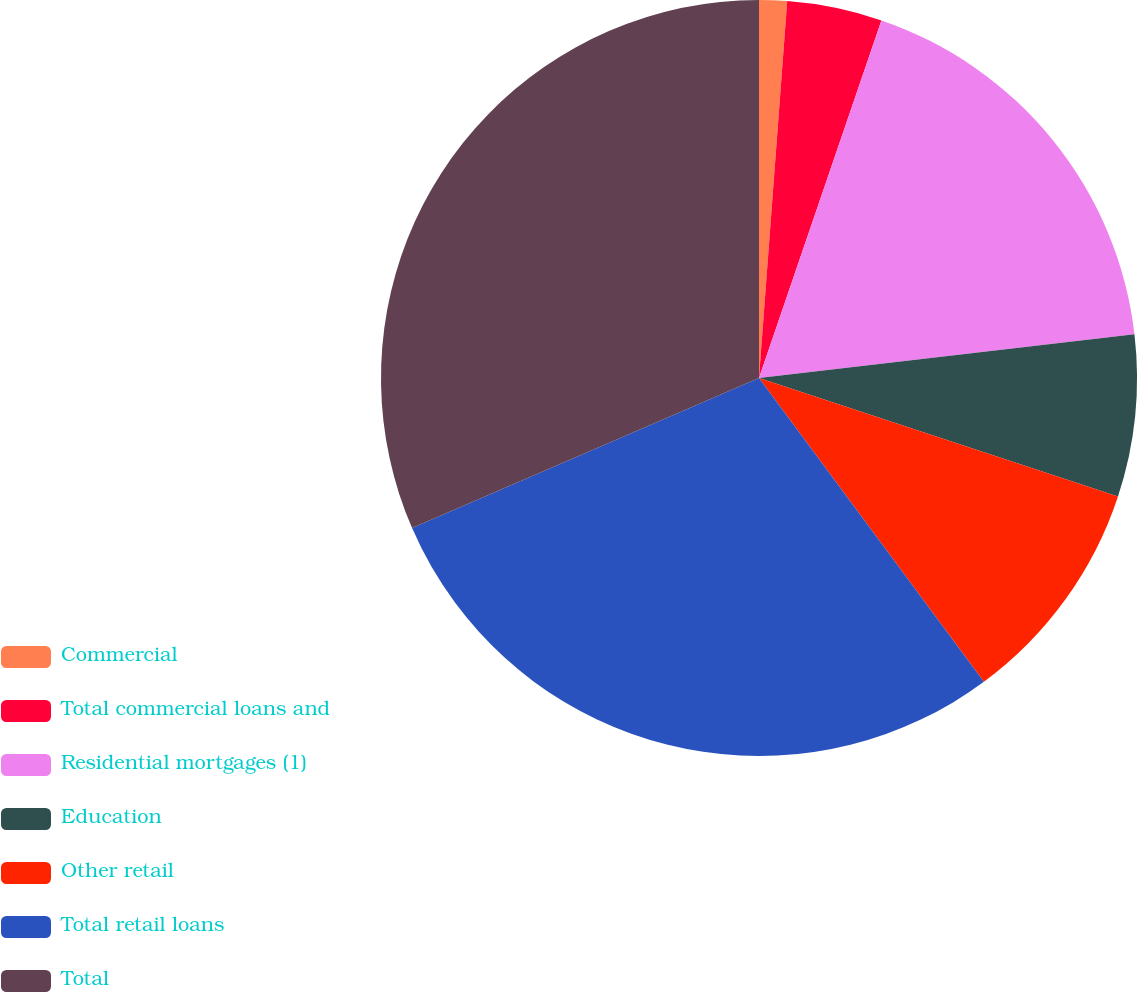Convert chart to OTSL. <chart><loc_0><loc_0><loc_500><loc_500><pie_chart><fcel>Commercial<fcel>Total commercial loans and<fcel>Residential mortgages (1)<fcel>Education<fcel>Other retail<fcel>Total retail loans<fcel>Total<nl><fcel>1.19%<fcel>4.06%<fcel>17.9%<fcel>6.92%<fcel>9.79%<fcel>28.64%<fcel>31.5%<nl></chart> 